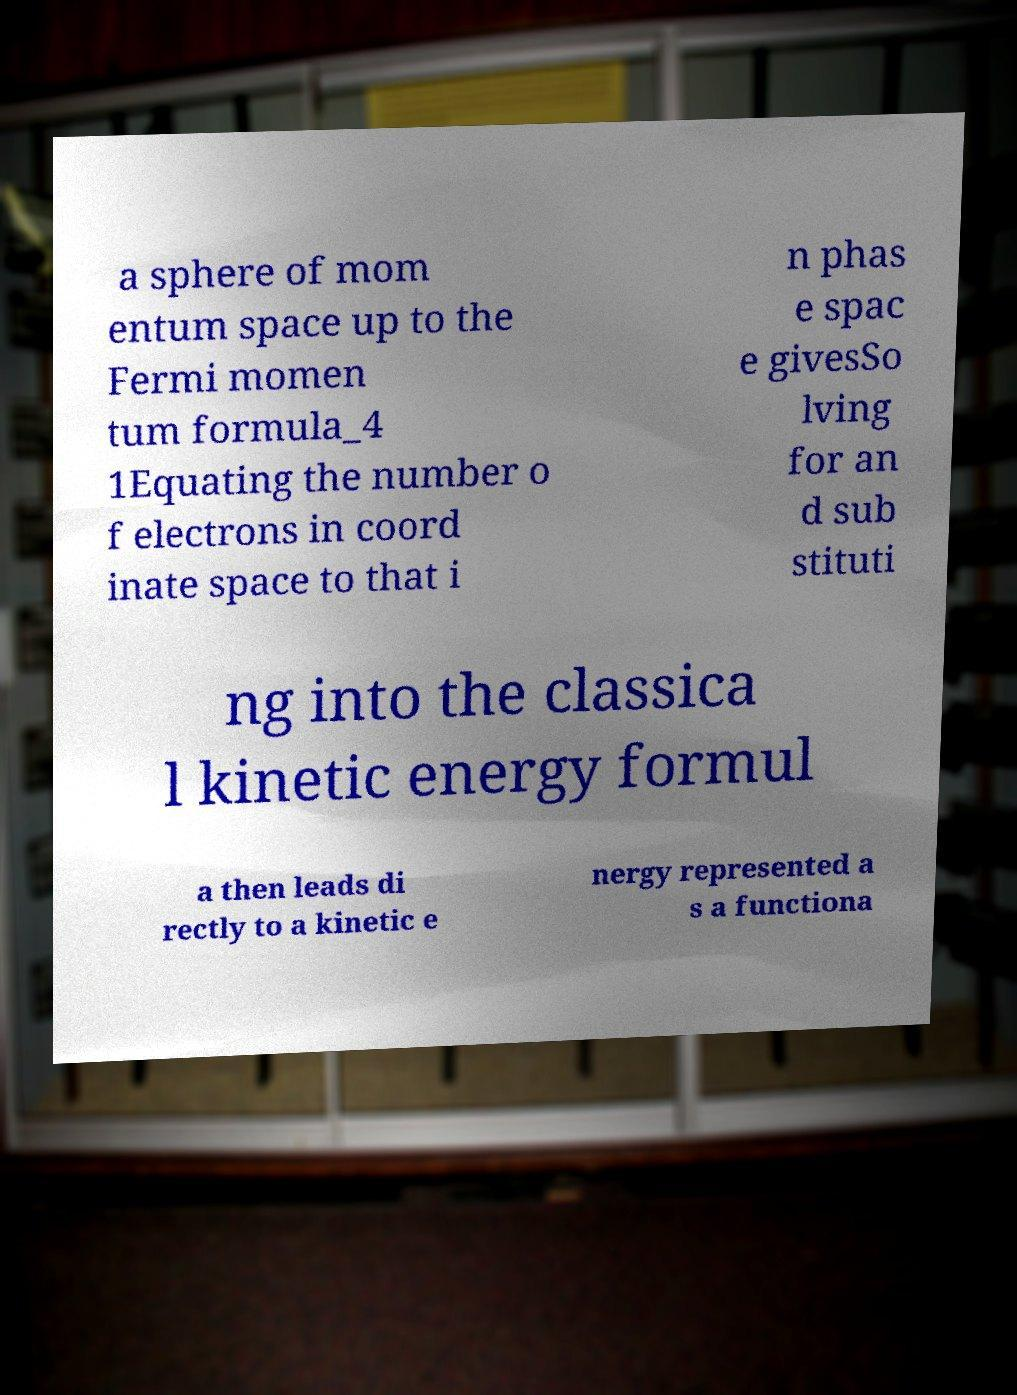For documentation purposes, I need the text within this image transcribed. Could you provide that? a sphere of mom entum space up to the Fermi momen tum formula_4 1Equating the number o f electrons in coord inate space to that i n phas e spac e givesSo lving for an d sub stituti ng into the classica l kinetic energy formul a then leads di rectly to a kinetic e nergy represented a s a functiona 